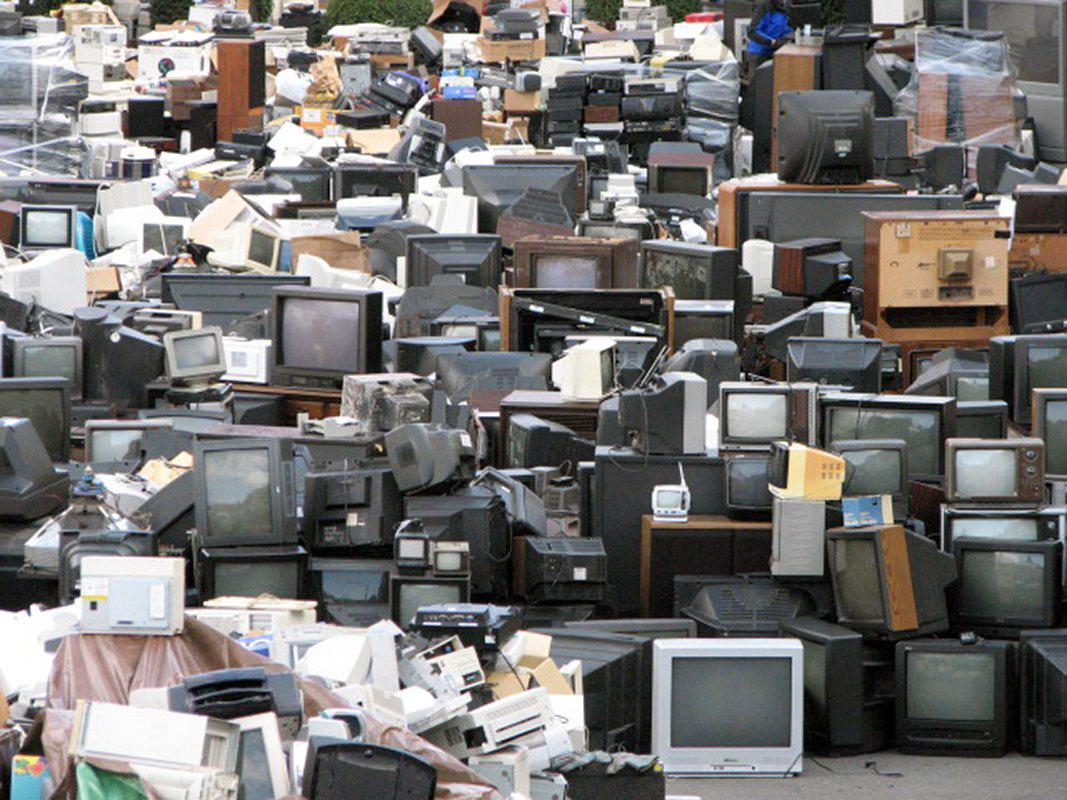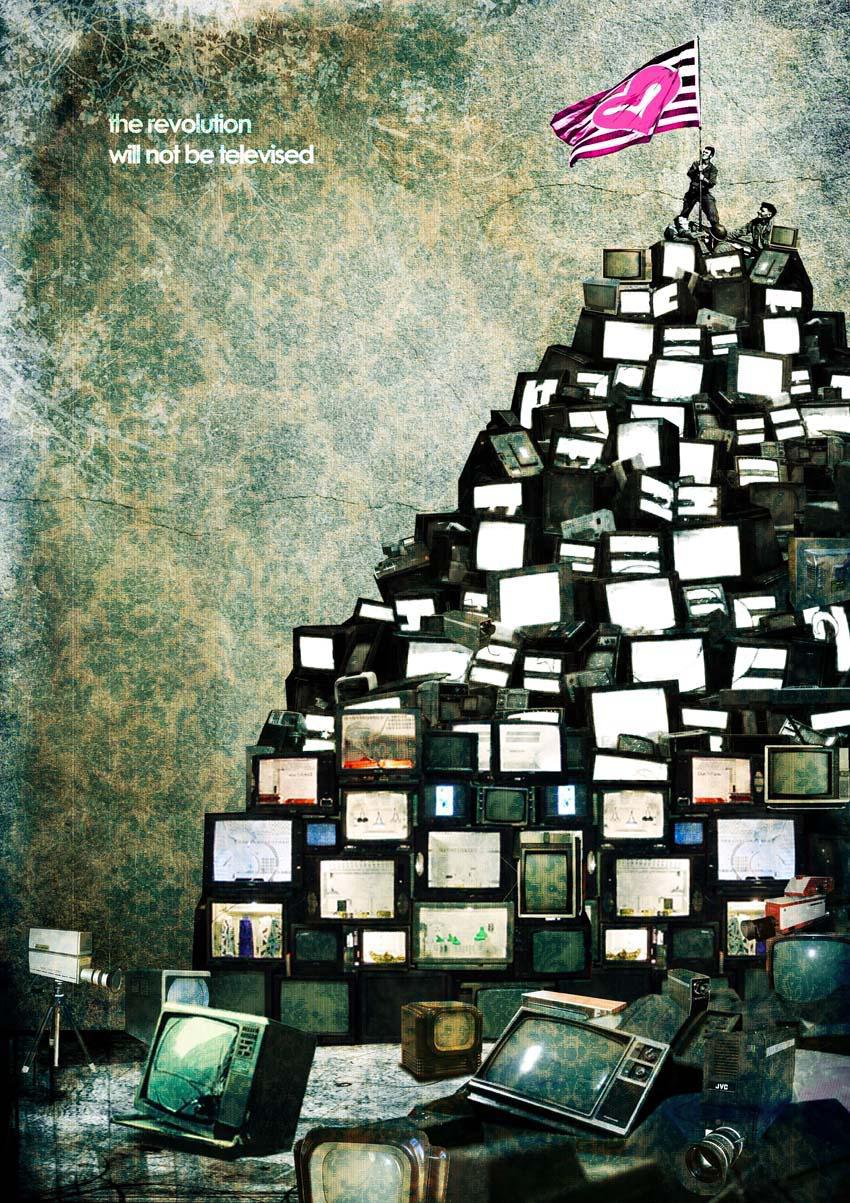The first image is the image on the left, the second image is the image on the right. Considering the images on both sides, is "An image shows TV-type appliances piled in a room in front of pattered wallpaper." valid? Answer yes or no. Yes. 